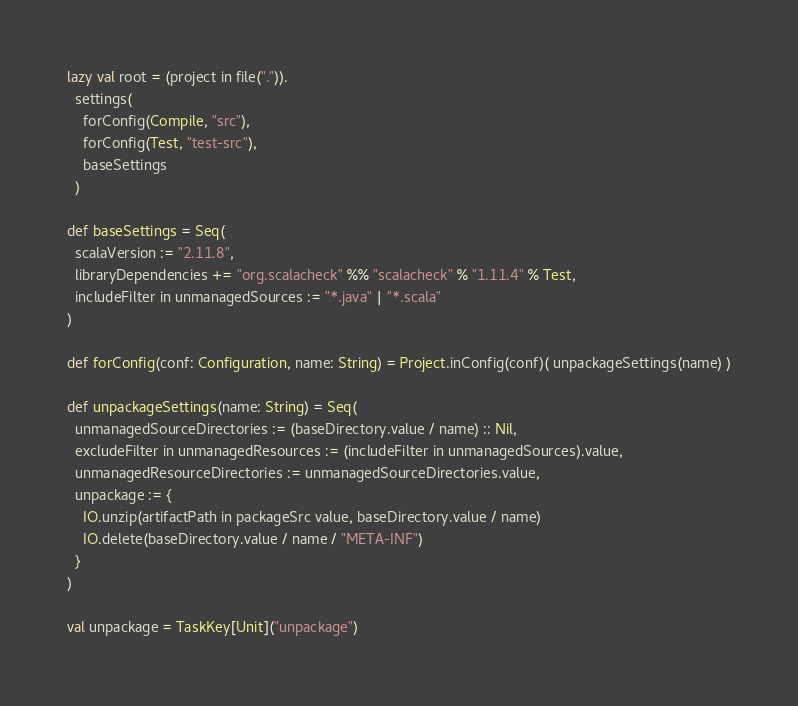Convert code to text. <code><loc_0><loc_0><loc_500><loc_500><_Scala_>lazy val root = (project in file(".")).
  settings(
    forConfig(Compile, "src"),
    forConfig(Test, "test-src"),
    baseSettings
  )

def baseSettings = Seq(
  scalaVersion := "2.11.8",
  libraryDependencies += "org.scalacheck" %% "scalacheck" % "1.11.4" % Test,
  includeFilter in unmanagedSources := "*.java" | "*.scala"
)

def forConfig(conf: Configuration, name: String) = Project.inConfig(conf)( unpackageSettings(name) )

def unpackageSettings(name: String) = Seq(
  unmanagedSourceDirectories := (baseDirectory.value / name) :: Nil,
  excludeFilter in unmanagedResources := (includeFilter in unmanagedSources).value,
  unmanagedResourceDirectories := unmanagedSourceDirectories.value,
  unpackage := {
    IO.unzip(artifactPath in packageSrc value, baseDirectory.value / name)
    IO.delete(baseDirectory.value / name / "META-INF")
  }
)

val unpackage = TaskKey[Unit]("unpackage")
</code> 